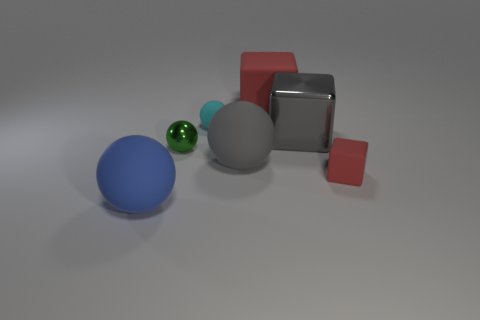Subtract all matte cubes. How many cubes are left? 1 Subtract all gray cubes. How many cubes are left? 2 Add 1 small green shiny objects. How many objects exist? 8 Subtract all balls. How many objects are left? 3 Subtract 3 blocks. How many blocks are left? 0 Subtract all green balls. Subtract all yellow cubes. How many balls are left? 3 Subtract all purple cylinders. How many blue blocks are left? 0 Subtract all big brown shiny blocks. Subtract all tiny red rubber things. How many objects are left? 6 Add 7 blue balls. How many blue balls are left? 8 Add 2 blue shiny cylinders. How many blue shiny cylinders exist? 2 